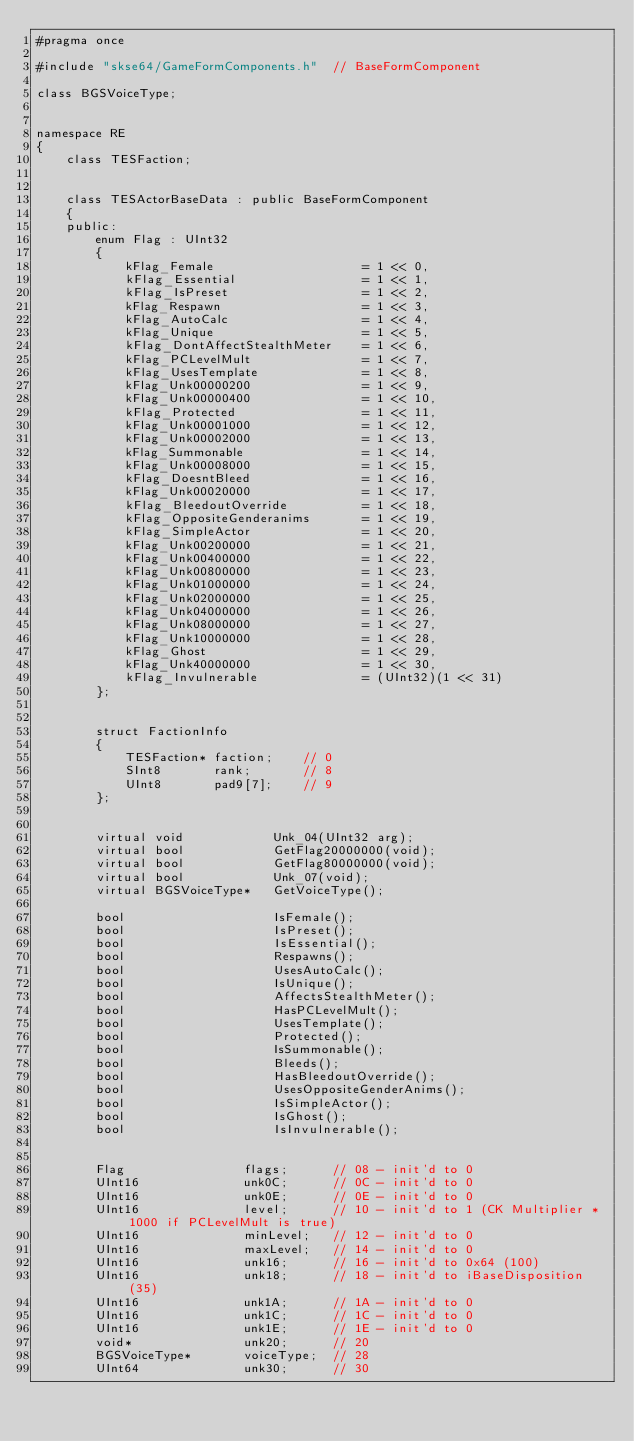<code> <loc_0><loc_0><loc_500><loc_500><_C_>#pragma once

#include "skse64/GameFormComponents.h"  // BaseFormComponent

class BGSVoiceType;


namespace RE
{
	class TESFaction;


	class TESActorBaseData : public BaseFormComponent
	{
	public:
		enum Flag : UInt32
		{
			kFlag_Female					= 1 << 0,
			kFlag_Essential					= 1 << 1,
			kFlag_IsPreset					= 1 << 2,
			kFlag_Respawn					= 1 << 3,
			kFlag_AutoCalc					= 1 << 4,
			kFlag_Unique					= 1 << 5,
			kFlag_DontAffectStealthMeter	= 1 << 6,
			kFlag_PCLevelMult				= 1 << 7,
			kFlag_UsesTemplate				= 1 << 8,
			kFlag_Unk00000200				= 1 << 9,
			kFlag_Unk00000400				= 1 << 10,
			kFlag_Protected					= 1 << 11,
			kFlag_Unk00001000				= 1 << 12,
			kFlag_Unk00002000				= 1 << 13,
			kFlag_Summonable				= 1 << 14,
			kFlag_Unk00008000				= 1 << 15,
			kFlag_DoesntBleed				= 1 << 16,
			kFlag_Unk00020000				= 1 << 17,
			kFlag_BleedoutOverride			= 1 << 18,
			kFlag_OppositeGenderanims		= 1 << 19,
			kFlag_SimpleActor				= 1 << 20,
			kFlag_Unk00200000				= 1 << 21,
			kFlag_Unk00400000				= 1 << 22,
			kFlag_Unk00800000				= 1 << 23,
			kFlag_Unk01000000				= 1 << 24,
			kFlag_Unk02000000				= 1 << 25,
			kFlag_Unk04000000				= 1 << 26,
			kFlag_Unk08000000				= 1 << 27,
			kFlag_Unk10000000				= 1 << 28,
			kFlag_Ghost						= 1 << 29,
			kFlag_Unk40000000				= 1 << 30,
			kFlag_Invulnerable				= (UInt32)(1 << 31)
		};


		struct FactionInfo
		{
			TESFaction*	faction;	// 0
			SInt8		rank;		// 8
			UInt8		pad9[7];	// 9
		};


		virtual void			Unk_04(UInt32 arg);
		virtual bool			GetFlag20000000(void);
		virtual bool			GetFlag80000000(void);
		virtual bool			Unk_07(void);
		virtual BGSVoiceType*	GetVoiceType();

		bool					IsFemale();
		bool					IsPreset();
		bool					IsEssential();
		bool					Respawns();
		bool					UsesAutoCalc();
		bool					IsUnique();
		bool					AffectsStealthMeter();
		bool					HasPCLevelMult();
		bool					UsesTemplate();
		bool					Protected();
		bool					IsSummonable();
		bool					Bleeds();
		bool					HasBleedoutOverride();
		bool					UsesOppositeGenderAnims();
		bool					IsSimpleActor();
		bool					IsGhost();
		bool					IsInvulnerable();


		Flag				flags;		// 08 - init'd to 0
		UInt16				unk0C;		// 0C - init'd to 0
		UInt16				unk0E;		// 0E - init'd to 0
		UInt16				level;		// 10 - init'd to 1	(CK Multiplier * 1000 if PCLevelMult is true)
		UInt16				minLevel;	// 12 - init'd to 0
		UInt16				maxLevel;	// 14 - init'd to 0
		UInt16				unk16;		// 16 - init'd to 0x64 (100)
		UInt16				unk18;		// 18 - init'd to iBaseDisposition (35)
		UInt16				unk1A;		// 1A - init'd to 0
		UInt16				unk1C;		// 1C - init'd to 0
		UInt16				unk1E;		// 1E - init'd to 0
		void*				unk20;		// 20
		BGSVoiceType*		voiceType;	// 28
		UInt64				unk30;		// 30</code> 